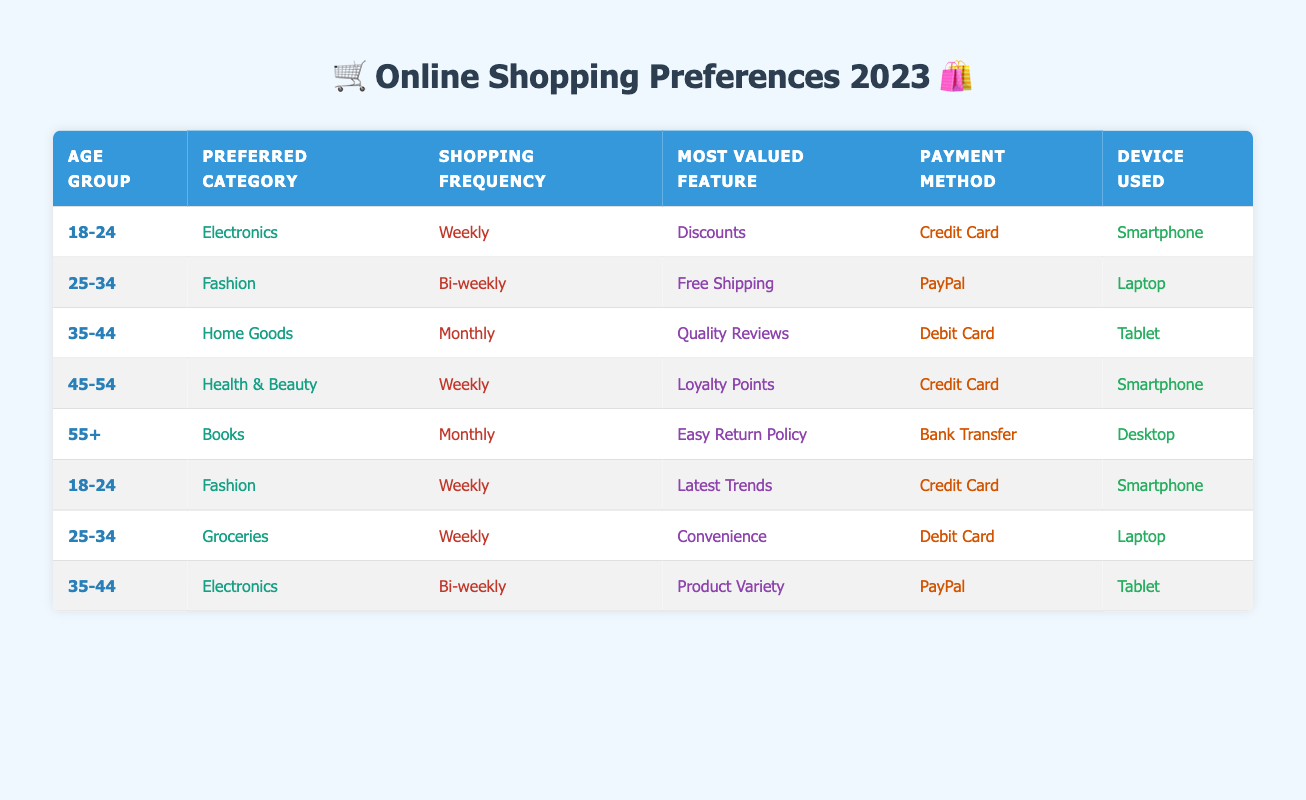What is the preferred category for the age group 25-34? In the table, under the row for the age group 25-34, we can see that the preferred category is Fashion.
Answer: Fashion How frequently do customers aged 45-54 shop online? Looking at the row corresponding to the age group 45-54, it indicates that their shopping frequency is Weekly.
Answer: Weekly What is the most valued feature among customers aged 18-24 who prefer Fashion? There are two entries for the age group 18-24 that have Fashion as the preferred category. One values Discounts, and the other values Latest Trends. Therefore, both features are valued by them.
Answer: Discounts and Latest Trends Is PayPal a payment method preferred by customers aged 35-44? Checking the two rows for customers aged 35-44, one row shows PayPal as the payment method, while the other shows Debit Card. Hence, PayPal is preferred by at least one customer.
Answer: Yes What percentage of customers prefers to shop Monthly compared to those who shop Weekly? There are two customers who shop Monthly and four who shop Weekly. The percentage of Monthly shoppers is (2/8)*100 = 25%, while the percentage of Weekly shoppers is (4/8)*100 = 50%.
Answer: 25% Monthly shoppers, 50% Weekly shoppers Which payment method is used most frequently by customers aged 25-34? We have two entries in the table for customers aged 25-34, one using PayPal for Fashion and the other using Debit Card for Groceries. Both methods are present, so we cannot determine a single most frequent method among them.
Answer: Not determinable Are more customers using smartphones or laptops for shopping? By counting the rows based on the device used, we find four customers using smartphones (from age groups 18-24 and 45-54) versus three using laptops (from age groups 25-34). Smartphones are therefore more frequently used.
Answer: Smartphones are used more What is the most popular payment method among customers who prefer health and beauty? The table shows that the payment method for health and beauty is Credit Card in the entry for age group 45-54, indicating that it is the one used here, making it the most popular.
Answer: Credit Card 